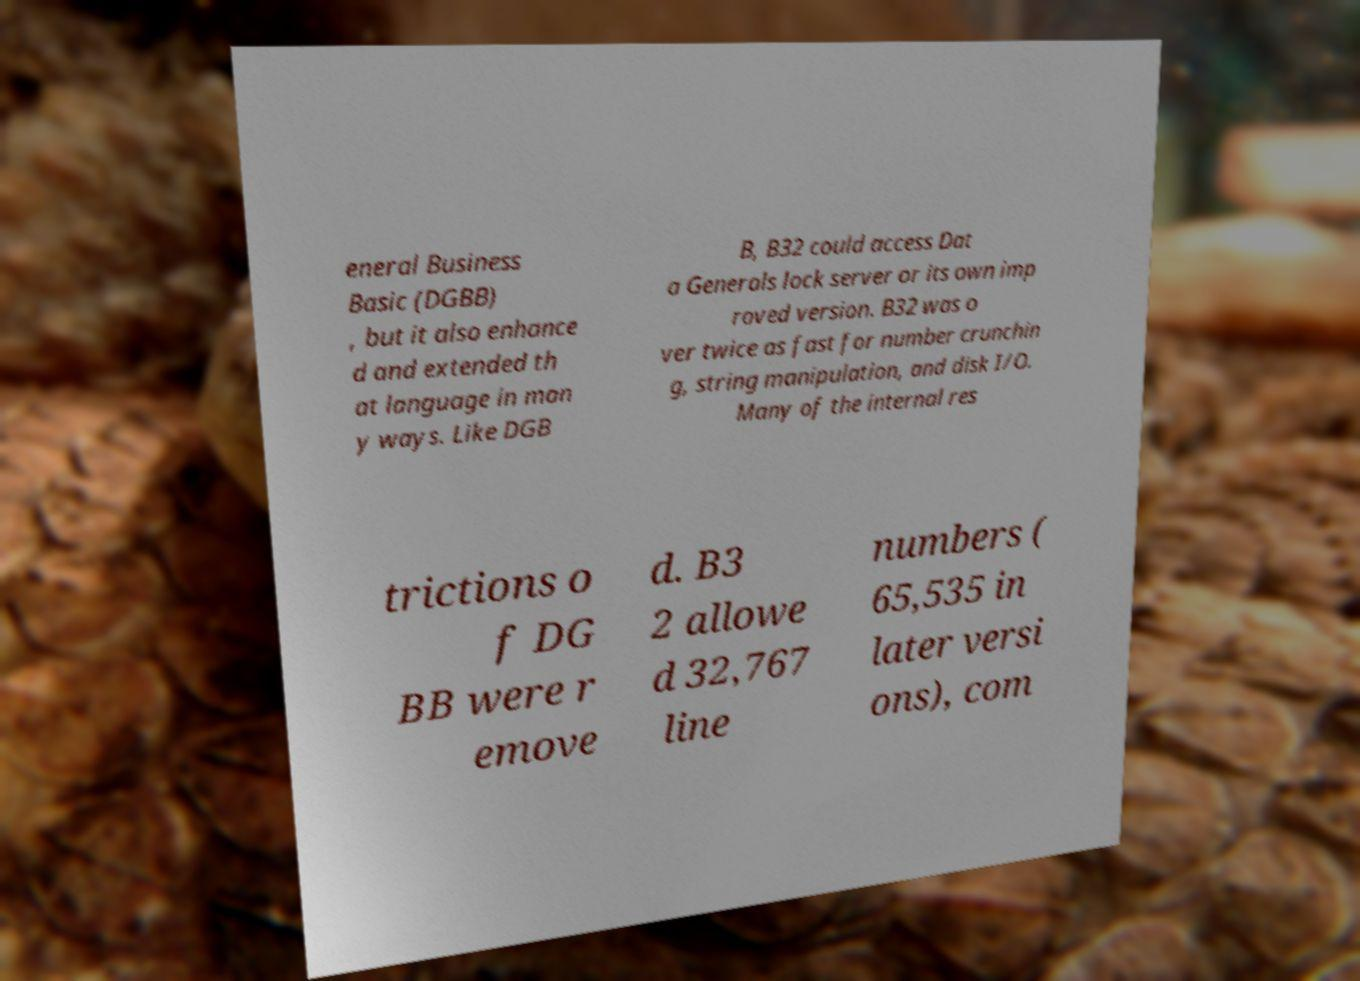Can you accurately transcribe the text from the provided image for me? eneral Business Basic (DGBB) , but it also enhance d and extended th at language in man y ways. Like DGB B, B32 could access Dat a Generals lock server or its own imp roved version. B32 was o ver twice as fast for number crunchin g, string manipulation, and disk I/O. Many of the internal res trictions o f DG BB were r emove d. B3 2 allowe d 32,767 line numbers ( 65,535 in later versi ons), com 